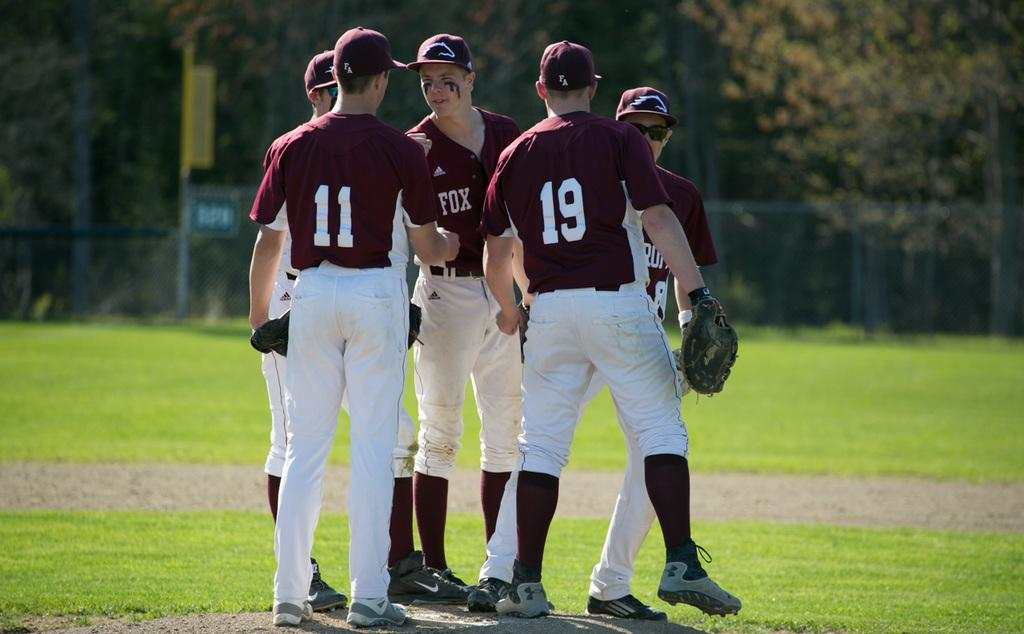Provide a one-sentence caption for the provided image. A group of five baseball players wearing Adidas maroon jerseys are huddled on a field. 